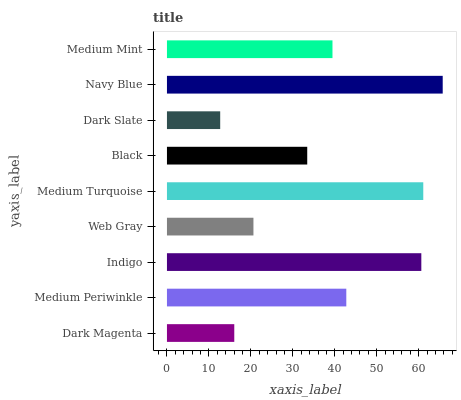Is Dark Slate the minimum?
Answer yes or no. Yes. Is Navy Blue the maximum?
Answer yes or no. Yes. Is Medium Periwinkle the minimum?
Answer yes or no. No. Is Medium Periwinkle the maximum?
Answer yes or no. No. Is Medium Periwinkle greater than Dark Magenta?
Answer yes or no. Yes. Is Dark Magenta less than Medium Periwinkle?
Answer yes or no. Yes. Is Dark Magenta greater than Medium Periwinkle?
Answer yes or no. No. Is Medium Periwinkle less than Dark Magenta?
Answer yes or no. No. Is Medium Mint the high median?
Answer yes or no. Yes. Is Medium Mint the low median?
Answer yes or no. Yes. Is Dark Magenta the high median?
Answer yes or no. No. Is Navy Blue the low median?
Answer yes or no. No. 